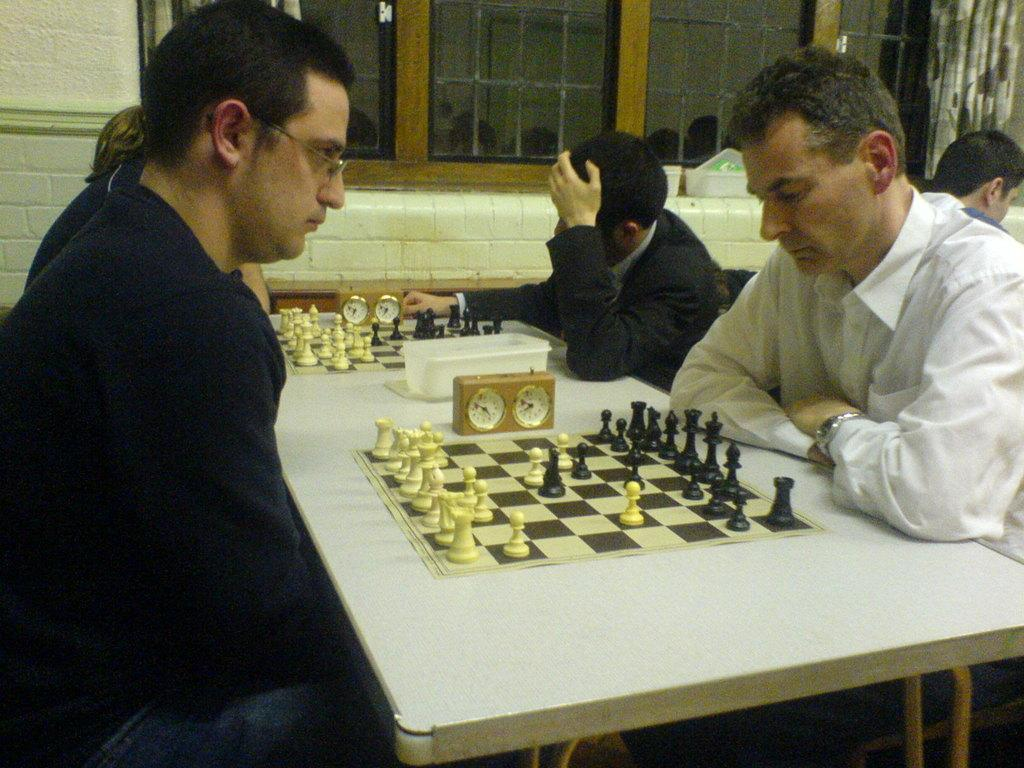What are the persons in the image doing? The persons in the image are sitting on a chair. What is in front of the persons? There is a table in front of the persons. What objects can be seen on the table? There is a clock, a container, a chess board, and coins on the table. Is there any source of natural light in the room? Yes, there is a window in the room. Reasoning: Let' Let's think step by step in order to produce the conversation. We start by identifying the main subjects in the image, which are the persons sitting on a chair. Then, we describe the objects and items that are in front of them, specifically the table and its contents. Finally, we mention the presence of a window, which indicates a source of natural light in the room. Absurd Question/Answer: How many fifths are present in the image? There is no reference to a "fifth" in the image, so it cannot be counted or quantified. What type of cars can be seen in the image? There are no cars present in the image. 